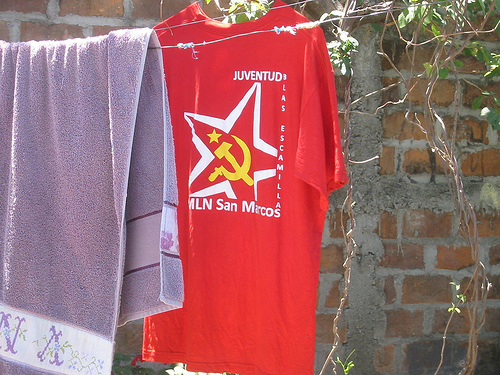<image>
Is the towel in the shirt? No. The towel is not contained within the shirt. These objects have a different spatial relationship. Where is the towel in relation to the leaves? Is it to the left of the leaves? Yes. From this viewpoint, the towel is positioned to the left side relative to the leaves. 